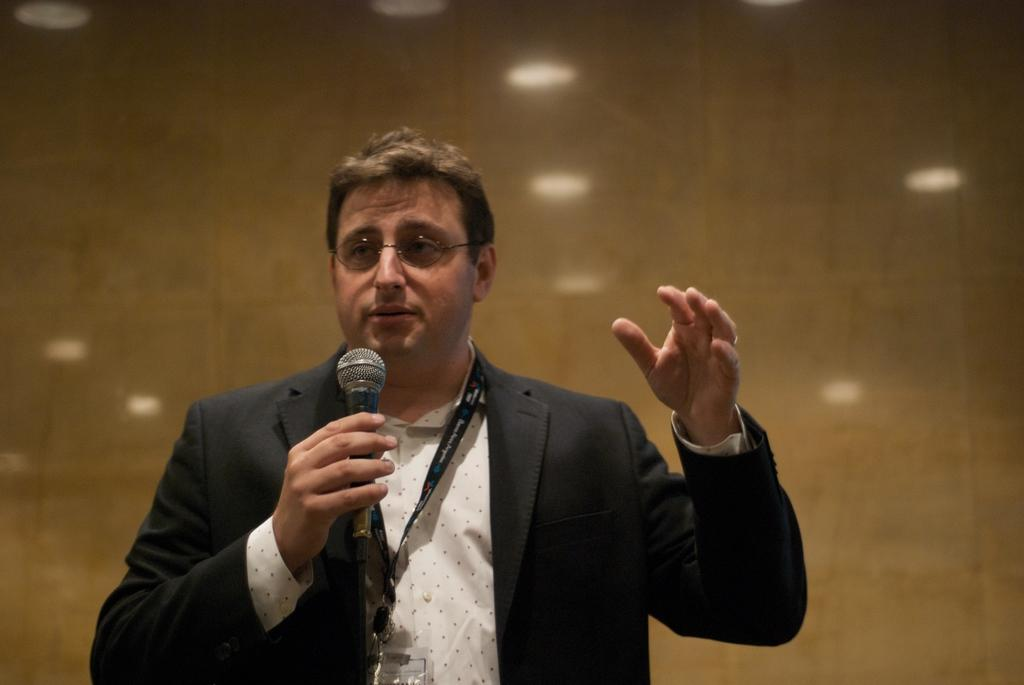What is the main subject of the image? There is a man in the image. What is the man wearing? The man is wearing a black suit. What is the man holding in the image? The man is holding a microphone. What type of accessory is the man wearing? The man is wearing glasses. What color is the wall in the background of the image? There is a brown-colored wall in the background of the image. What type of potato is visible on the bed in the image? There is no potato or bed present in the image; it features a man holding a microphone in front of a brown-colored wall. What kind of stone can be seen on the man's shoes in the image? There is no mention of the man's shoes or any stones in the image. 